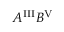<formula> <loc_0><loc_0><loc_500><loc_500>A ^ { I I I } B ^ { V }</formula> 